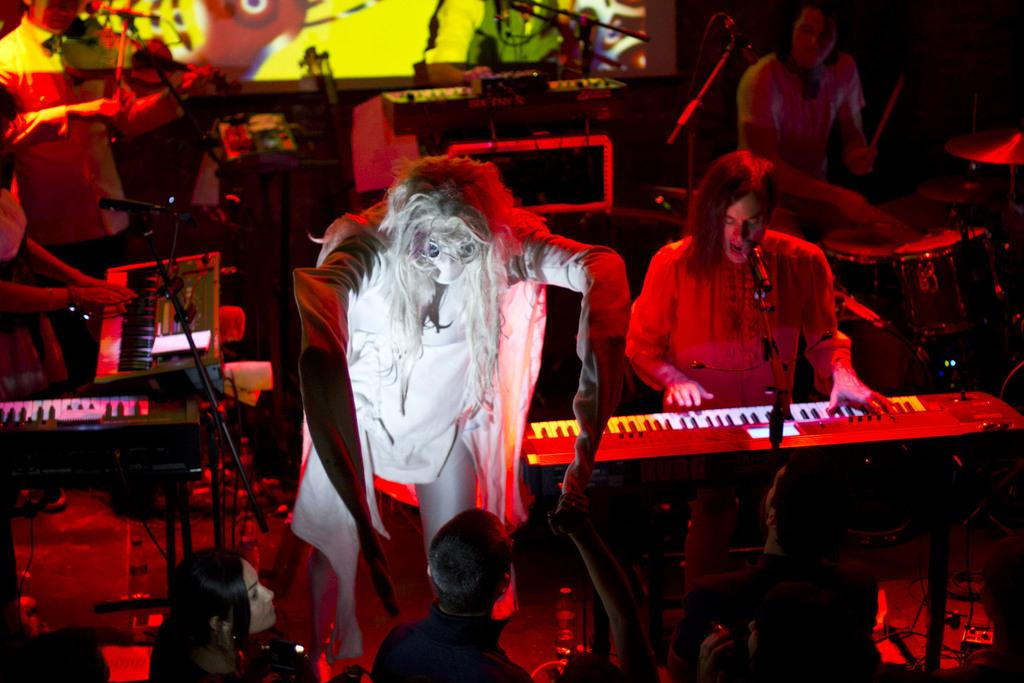What is the person in the image dressed as? The person in the image is dressed in a Halloween costume. Where is the person performing? The person is performing on a stage. What instruments are the musicians playing? The musicians are playing keyboard and drums. What type of jeans is the stranger wearing in the image? There is no stranger present in the image, and therefore no information about their jeans can be provided. 